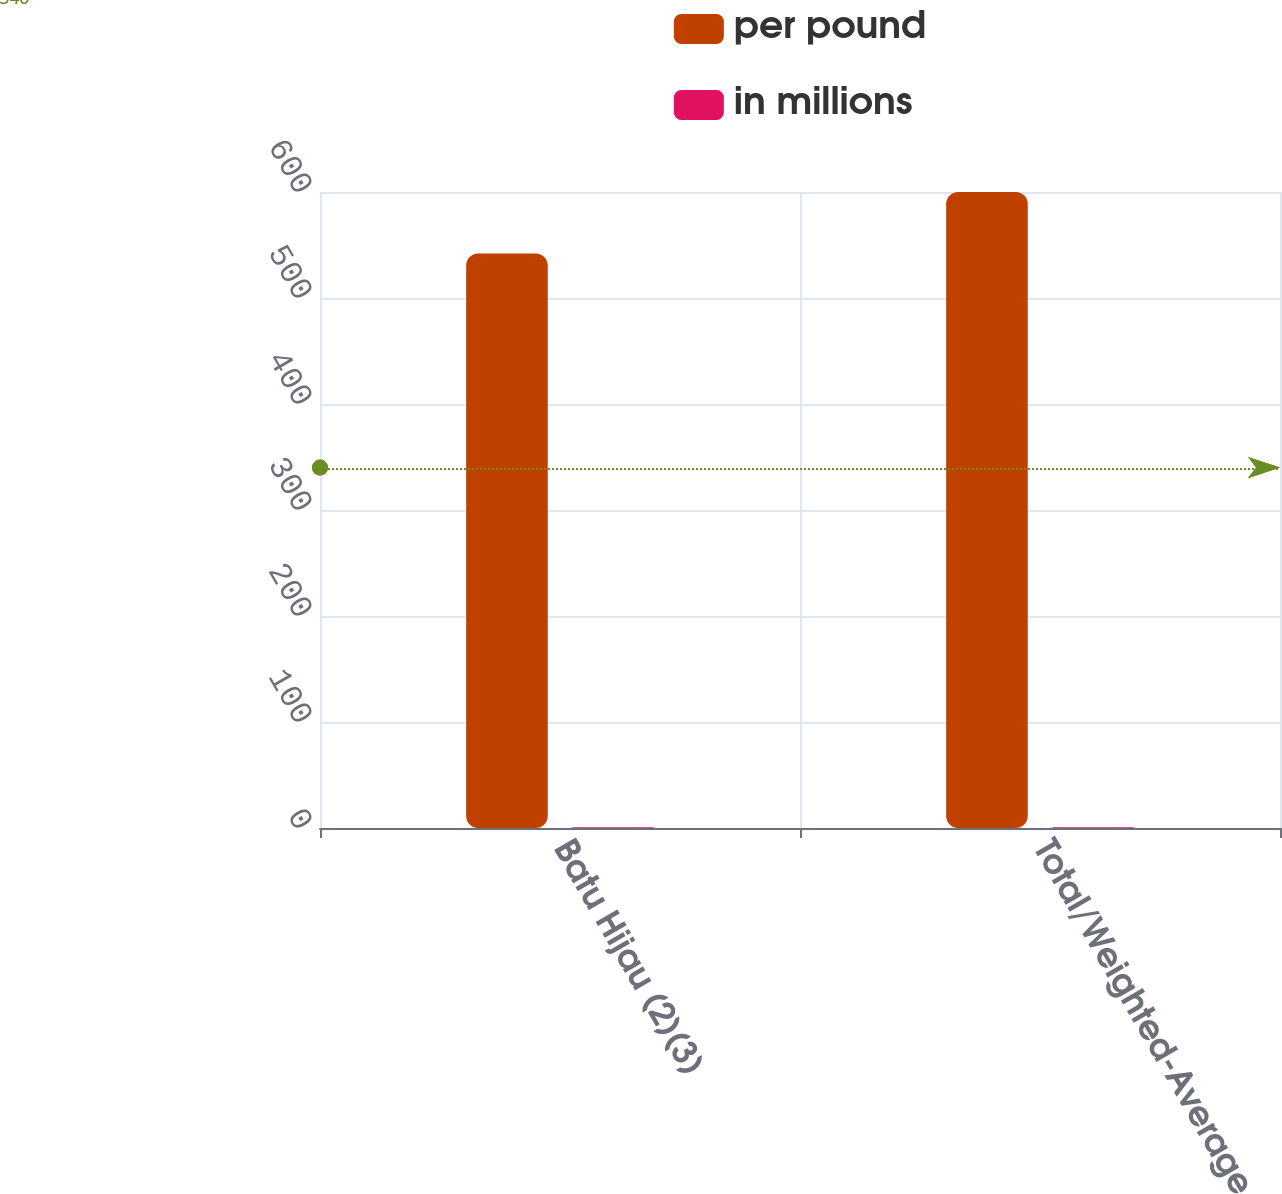Convert chart. <chart><loc_0><loc_0><loc_500><loc_500><stacked_bar_chart><ecel><fcel>Batu Hijau (2)(3)<fcel>Total/Weighted-Average<nl><fcel>per pound<fcel>542<fcel>600<nl><fcel>in millions<fcel>0.69<fcel>0.8<nl></chart> 